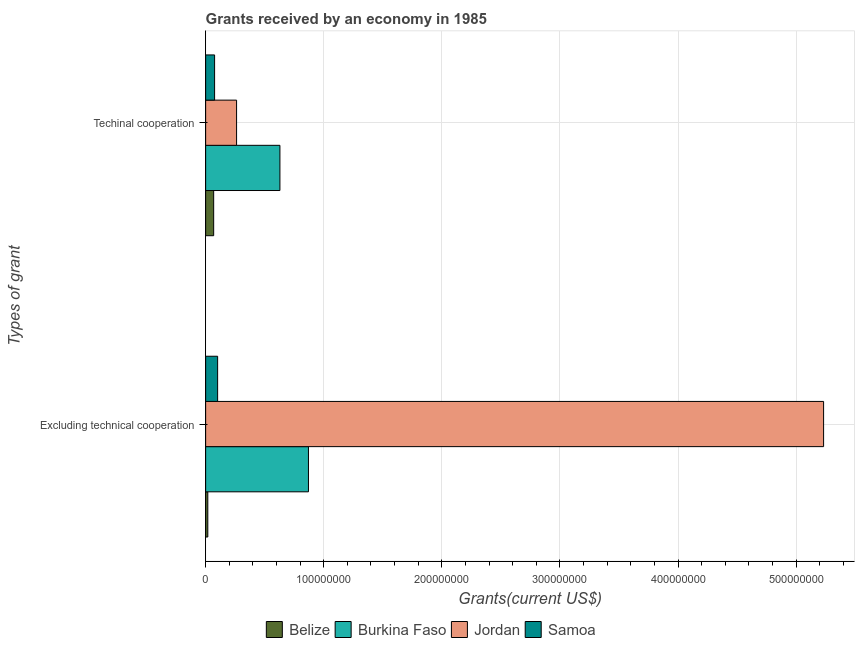What is the label of the 1st group of bars from the top?
Your answer should be very brief. Techinal cooperation. What is the amount of grants received(excluding technical cooperation) in Samoa?
Offer a very short reply. 1.02e+07. Across all countries, what is the maximum amount of grants received(including technical cooperation)?
Give a very brief answer. 6.29e+07. Across all countries, what is the minimum amount of grants received(excluding technical cooperation)?
Your response must be concise. 1.84e+06. In which country was the amount of grants received(including technical cooperation) maximum?
Give a very brief answer. Burkina Faso. In which country was the amount of grants received(excluding technical cooperation) minimum?
Make the answer very short. Belize. What is the total amount of grants received(excluding technical cooperation) in the graph?
Make the answer very short. 6.22e+08. What is the difference between the amount of grants received(including technical cooperation) in Samoa and that in Jordan?
Provide a succinct answer. -1.86e+07. What is the difference between the amount of grants received(excluding technical cooperation) in Belize and the amount of grants received(including technical cooperation) in Samoa?
Keep it short and to the point. -5.74e+06. What is the average amount of grants received(excluding technical cooperation) per country?
Offer a very short reply. 1.56e+08. What is the difference between the amount of grants received(excluding technical cooperation) and amount of grants received(including technical cooperation) in Samoa?
Your response must be concise. 2.57e+06. In how many countries, is the amount of grants received(including technical cooperation) greater than 500000000 US$?
Offer a terse response. 0. What is the ratio of the amount of grants received(excluding technical cooperation) in Jordan to that in Samoa?
Make the answer very short. 51.55. What does the 2nd bar from the top in Excluding technical cooperation represents?
Provide a short and direct response. Jordan. What does the 1st bar from the bottom in Excluding technical cooperation represents?
Provide a short and direct response. Belize. Are the values on the major ticks of X-axis written in scientific E-notation?
Offer a very short reply. No. Does the graph contain any zero values?
Give a very brief answer. No. Does the graph contain grids?
Provide a succinct answer. Yes. How many legend labels are there?
Ensure brevity in your answer.  4. How are the legend labels stacked?
Your response must be concise. Horizontal. What is the title of the graph?
Your response must be concise. Grants received by an economy in 1985. Does "Virgin Islands" appear as one of the legend labels in the graph?
Provide a short and direct response. No. What is the label or title of the X-axis?
Provide a short and direct response. Grants(current US$). What is the label or title of the Y-axis?
Make the answer very short. Types of grant. What is the Grants(current US$) in Belize in Excluding technical cooperation?
Your response must be concise. 1.84e+06. What is the Grants(current US$) of Burkina Faso in Excluding technical cooperation?
Provide a succinct answer. 8.71e+07. What is the Grants(current US$) of Jordan in Excluding technical cooperation?
Provide a short and direct response. 5.23e+08. What is the Grants(current US$) in Samoa in Excluding technical cooperation?
Offer a terse response. 1.02e+07. What is the Grants(current US$) of Belize in Techinal cooperation?
Make the answer very short. 6.80e+06. What is the Grants(current US$) in Burkina Faso in Techinal cooperation?
Give a very brief answer. 6.29e+07. What is the Grants(current US$) of Jordan in Techinal cooperation?
Make the answer very short. 2.62e+07. What is the Grants(current US$) of Samoa in Techinal cooperation?
Your answer should be very brief. 7.58e+06. Across all Types of grant, what is the maximum Grants(current US$) in Belize?
Offer a terse response. 6.80e+06. Across all Types of grant, what is the maximum Grants(current US$) in Burkina Faso?
Provide a succinct answer. 8.71e+07. Across all Types of grant, what is the maximum Grants(current US$) of Jordan?
Your answer should be very brief. 5.23e+08. Across all Types of grant, what is the maximum Grants(current US$) of Samoa?
Your answer should be very brief. 1.02e+07. Across all Types of grant, what is the minimum Grants(current US$) in Belize?
Give a very brief answer. 1.84e+06. Across all Types of grant, what is the minimum Grants(current US$) of Burkina Faso?
Your response must be concise. 6.29e+07. Across all Types of grant, what is the minimum Grants(current US$) in Jordan?
Your answer should be compact. 2.62e+07. Across all Types of grant, what is the minimum Grants(current US$) in Samoa?
Your answer should be compact. 7.58e+06. What is the total Grants(current US$) of Belize in the graph?
Offer a terse response. 8.64e+06. What is the total Grants(current US$) in Burkina Faso in the graph?
Make the answer very short. 1.50e+08. What is the total Grants(current US$) of Jordan in the graph?
Offer a very short reply. 5.49e+08. What is the total Grants(current US$) of Samoa in the graph?
Your response must be concise. 1.77e+07. What is the difference between the Grants(current US$) of Belize in Excluding technical cooperation and that in Techinal cooperation?
Keep it short and to the point. -4.96e+06. What is the difference between the Grants(current US$) in Burkina Faso in Excluding technical cooperation and that in Techinal cooperation?
Give a very brief answer. 2.42e+07. What is the difference between the Grants(current US$) in Jordan in Excluding technical cooperation and that in Techinal cooperation?
Provide a short and direct response. 4.97e+08. What is the difference between the Grants(current US$) in Samoa in Excluding technical cooperation and that in Techinal cooperation?
Ensure brevity in your answer.  2.57e+06. What is the difference between the Grants(current US$) of Belize in Excluding technical cooperation and the Grants(current US$) of Burkina Faso in Techinal cooperation?
Provide a succinct answer. -6.11e+07. What is the difference between the Grants(current US$) in Belize in Excluding technical cooperation and the Grants(current US$) in Jordan in Techinal cooperation?
Offer a very short reply. -2.44e+07. What is the difference between the Grants(current US$) of Belize in Excluding technical cooperation and the Grants(current US$) of Samoa in Techinal cooperation?
Give a very brief answer. -5.74e+06. What is the difference between the Grants(current US$) of Burkina Faso in Excluding technical cooperation and the Grants(current US$) of Jordan in Techinal cooperation?
Give a very brief answer. 6.09e+07. What is the difference between the Grants(current US$) of Burkina Faso in Excluding technical cooperation and the Grants(current US$) of Samoa in Techinal cooperation?
Provide a short and direct response. 7.95e+07. What is the difference between the Grants(current US$) of Jordan in Excluding technical cooperation and the Grants(current US$) of Samoa in Techinal cooperation?
Make the answer very short. 5.16e+08. What is the average Grants(current US$) of Belize per Types of grant?
Provide a succinct answer. 4.32e+06. What is the average Grants(current US$) of Burkina Faso per Types of grant?
Your answer should be compact. 7.50e+07. What is the average Grants(current US$) of Jordan per Types of grant?
Offer a very short reply. 2.75e+08. What is the average Grants(current US$) in Samoa per Types of grant?
Keep it short and to the point. 8.86e+06. What is the difference between the Grants(current US$) of Belize and Grants(current US$) of Burkina Faso in Excluding technical cooperation?
Provide a succinct answer. -8.52e+07. What is the difference between the Grants(current US$) in Belize and Grants(current US$) in Jordan in Excluding technical cooperation?
Ensure brevity in your answer.  -5.21e+08. What is the difference between the Grants(current US$) in Belize and Grants(current US$) in Samoa in Excluding technical cooperation?
Your answer should be compact. -8.31e+06. What is the difference between the Grants(current US$) in Burkina Faso and Grants(current US$) in Jordan in Excluding technical cooperation?
Provide a succinct answer. -4.36e+08. What is the difference between the Grants(current US$) in Burkina Faso and Grants(current US$) in Samoa in Excluding technical cooperation?
Your answer should be very brief. 7.69e+07. What is the difference between the Grants(current US$) of Jordan and Grants(current US$) of Samoa in Excluding technical cooperation?
Your answer should be very brief. 5.13e+08. What is the difference between the Grants(current US$) of Belize and Grants(current US$) of Burkina Faso in Techinal cooperation?
Offer a terse response. -5.61e+07. What is the difference between the Grants(current US$) of Belize and Grants(current US$) of Jordan in Techinal cooperation?
Offer a terse response. -1.94e+07. What is the difference between the Grants(current US$) in Belize and Grants(current US$) in Samoa in Techinal cooperation?
Offer a terse response. -7.80e+05. What is the difference between the Grants(current US$) in Burkina Faso and Grants(current US$) in Jordan in Techinal cooperation?
Your answer should be compact. 3.67e+07. What is the difference between the Grants(current US$) of Burkina Faso and Grants(current US$) of Samoa in Techinal cooperation?
Give a very brief answer. 5.53e+07. What is the difference between the Grants(current US$) in Jordan and Grants(current US$) in Samoa in Techinal cooperation?
Provide a short and direct response. 1.86e+07. What is the ratio of the Grants(current US$) of Belize in Excluding technical cooperation to that in Techinal cooperation?
Your response must be concise. 0.27. What is the ratio of the Grants(current US$) of Burkina Faso in Excluding technical cooperation to that in Techinal cooperation?
Offer a very short reply. 1.38. What is the ratio of the Grants(current US$) in Jordan in Excluding technical cooperation to that in Techinal cooperation?
Keep it short and to the point. 19.97. What is the ratio of the Grants(current US$) in Samoa in Excluding technical cooperation to that in Techinal cooperation?
Offer a terse response. 1.34. What is the difference between the highest and the second highest Grants(current US$) in Belize?
Offer a terse response. 4.96e+06. What is the difference between the highest and the second highest Grants(current US$) in Burkina Faso?
Make the answer very short. 2.42e+07. What is the difference between the highest and the second highest Grants(current US$) in Jordan?
Your answer should be compact. 4.97e+08. What is the difference between the highest and the second highest Grants(current US$) of Samoa?
Ensure brevity in your answer.  2.57e+06. What is the difference between the highest and the lowest Grants(current US$) of Belize?
Your response must be concise. 4.96e+06. What is the difference between the highest and the lowest Grants(current US$) in Burkina Faso?
Your answer should be very brief. 2.42e+07. What is the difference between the highest and the lowest Grants(current US$) in Jordan?
Your answer should be compact. 4.97e+08. What is the difference between the highest and the lowest Grants(current US$) in Samoa?
Make the answer very short. 2.57e+06. 